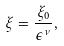Convert formula to latex. <formula><loc_0><loc_0><loc_500><loc_500>\xi = \frac { \xi _ { 0 } } { \epsilon ^ { \nu } } ,</formula> 